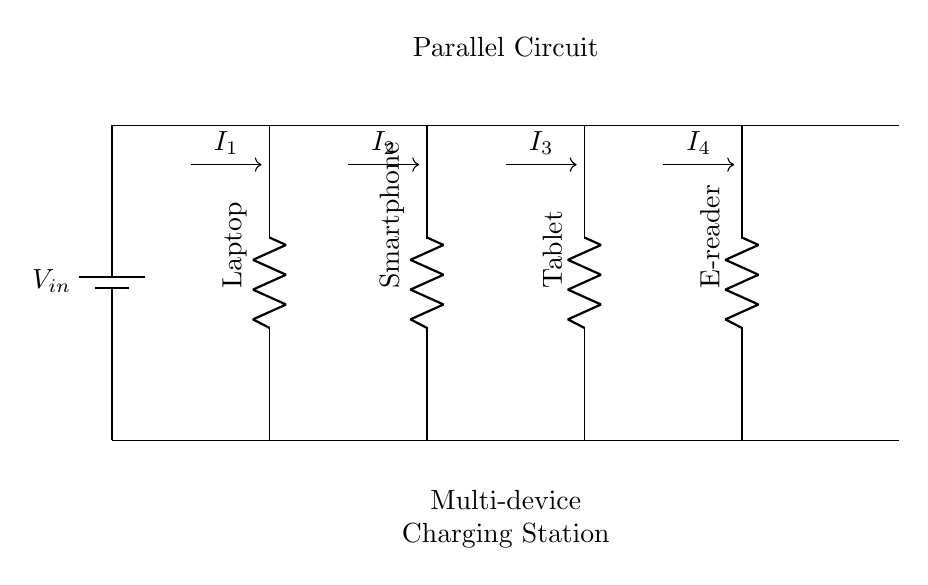What type of circuit is represented? The circuit is a parallel circuit, which is characterized by multiple branches, each connected directly to the same voltage source. In the diagram, you can see that each device is connected directly to the battery, indicating they receive the same voltage.
Answer: Parallel How many devices are connected? There are four devices connected in the circuit, as indicated by the four labeled resistors in the diagram: Laptop, Smartphone, Tablet, and E-reader. Each device is on a separate branch of the circuit.
Answer: Four What is the source voltage in the circuit? The source voltage, represented by the battery in the diagram, is labeled as \(V_{in}\). While the specific value of \(V_{in}\) is not given in the diagram, it is understood that all devices receive this same voltage.
Answer: \(V_{in}\) What can you say about the current in each branch? In a parallel circuit, the total current is divided among the branches. Each device has its own current denoted by \(I_1\), \(I_2\), \(I_3\), and \(I_4\). The sum of these currents equals the total current supplied by the source, demonstrating that each branch operates independently.
Answer: Divided What happens to the total resistance if one device is removed? If one device is removed from the parallel circuit, the total resistance of the circuit decreases. This is because removing a branch increases the total current drawn from the source, given that current takes the path of least resistance, thereby reducing the overall resistance calculated from the formula for parallel resistance.
Answer: Decreases How does the voltage across each device compare? The voltage across each device in a parallel circuit remains constant and is equal to the voltage of the power source. Since all devices are connected directly to the same terminals of the battery, they all experience the same potential difference.
Answer: Equal to \(V_{in}\) What is the function of the battery in this circuit? The battery serves as the power source, providing the necessary electrical energy to maintain a constant voltage throughout the parallel circuit. It ensures that all connected devices can charge simultaneously at the same voltage level.
Answer: Power source 